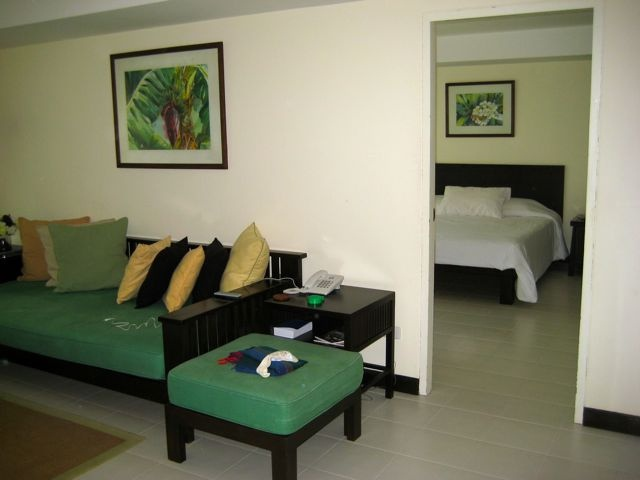Describe the objects in this image and their specific colors. I can see couch in gray, black, darkgreen, and tan tones and bed in gray, black, and darkgray tones in this image. 